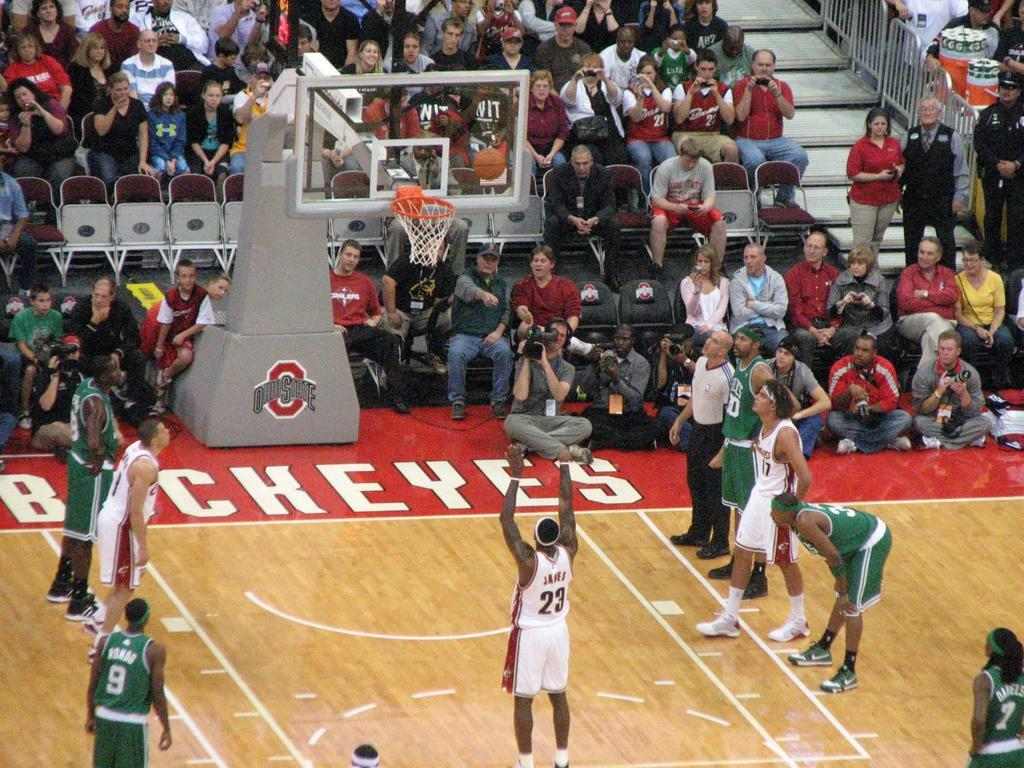<image>
Write a terse but informative summary of the picture. A basketball game with the word Buckeyes on the court. 